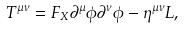Convert formula to latex. <formula><loc_0><loc_0><loc_500><loc_500>T ^ { \mu \nu } = F _ { X } \partial ^ { \mu } \phi \partial ^ { \nu } \phi - \eta ^ { \mu \nu } L ,</formula> 